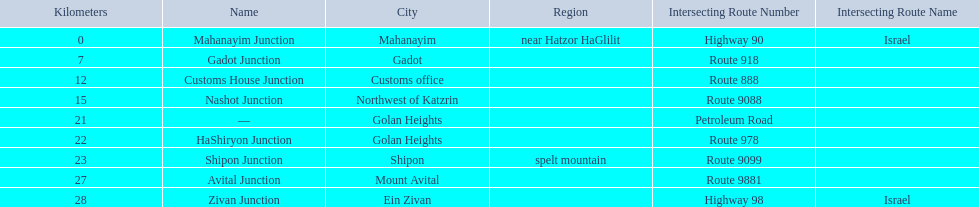What junction is the furthest from mahanayim junction? Zivan Junction. 